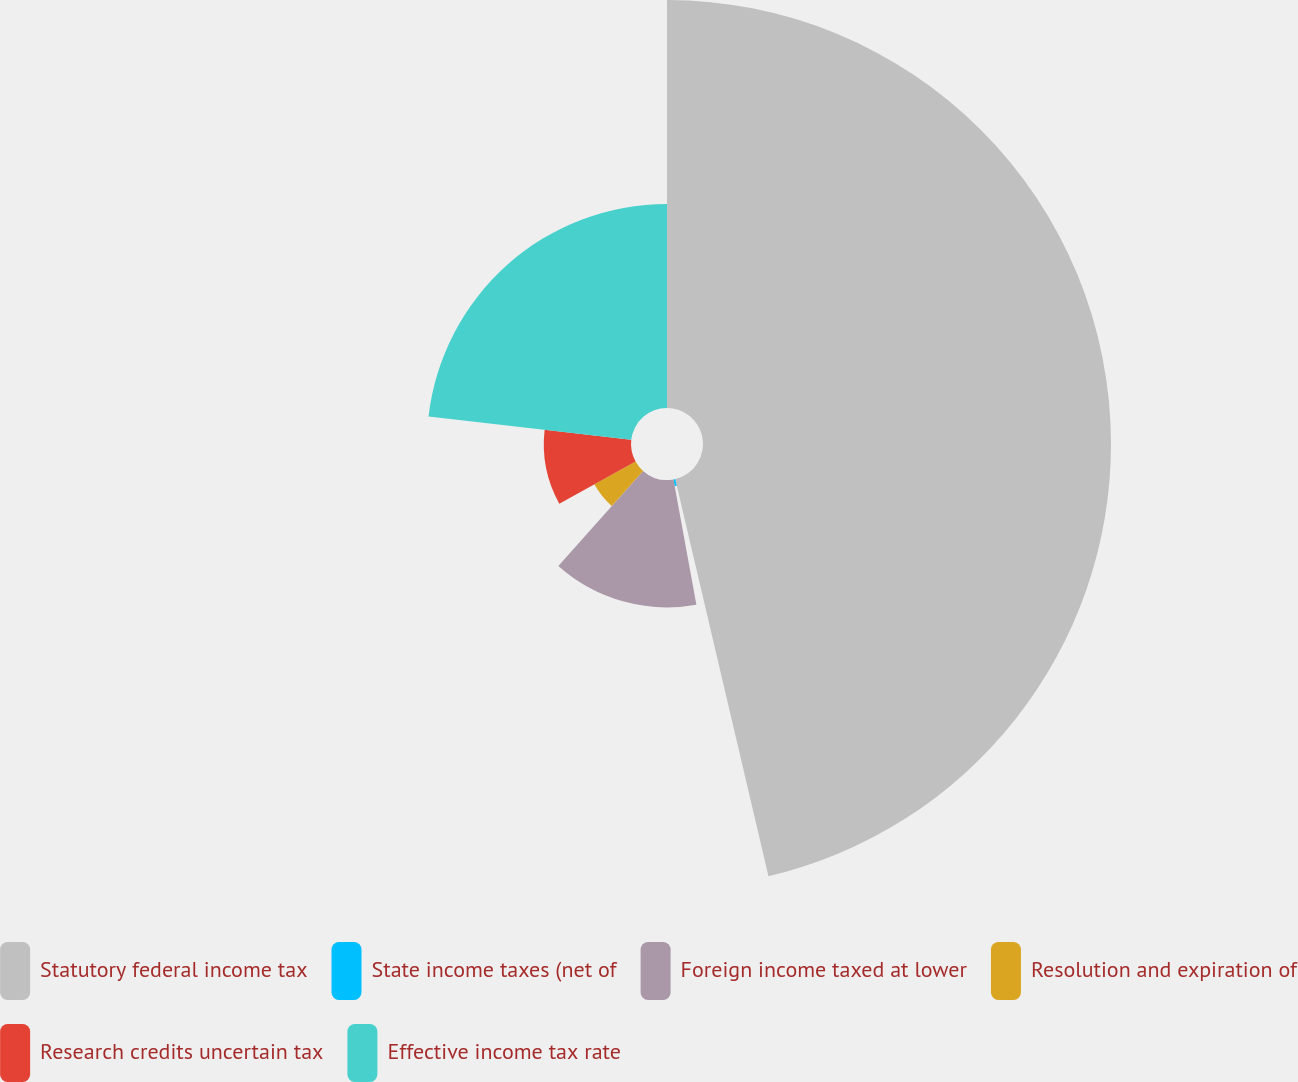Convert chart. <chart><loc_0><loc_0><loc_500><loc_500><pie_chart><fcel>Statutory federal income tax<fcel>State income taxes (net of<fcel>Foreign income taxed at lower<fcel>Resolution and expiration of<fcel>Research credits uncertain tax<fcel>Effective income tax rate<nl><fcel>46.33%<fcel>0.79%<fcel>14.46%<fcel>5.35%<fcel>9.9%<fcel>23.17%<nl></chart> 